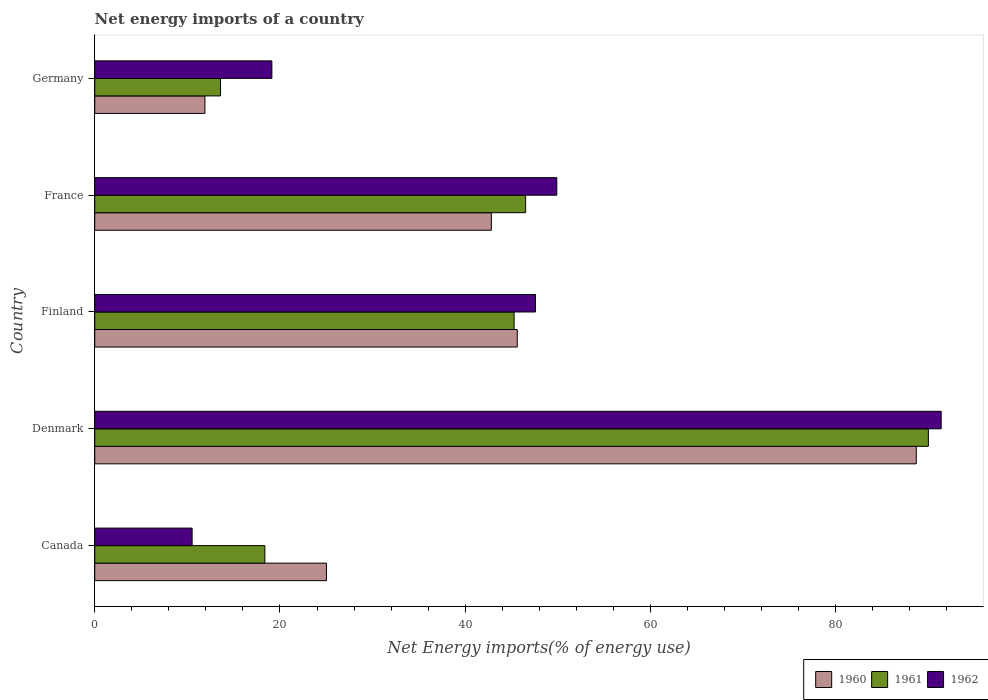How many groups of bars are there?
Keep it short and to the point. 5. Are the number of bars per tick equal to the number of legend labels?
Make the answer very short. Yes. How many bars are there on the 1st tick from the top?
Make the answer very short. 3. How many bars are there on the 1st tick from the bottom?
Offer a terse response. 3. What is the label of the 3rd group of bars from the top?
Make the answer very short. Finland. In how many cases, is the number of bars for a given country not equal to the number of legend labels?
Provide a short and direct response. 0. What is the net energy imports in 1962 in Finland?
Provide a short and direct response. 47.59. Across all countries, what is the maximum net energy imports in 1961?
Your response must be concise. 90.01. Across all countries, what is the minimum net energy imports in 1960?
Make the answer very short. 11.9. In which country was the net energy imports in 1960 maximum?
Provide a succinct answer. Denmark. In which country was the net energy imports in 1961 minimum?
Offer a very short reply. Germany. What is the total net energy imports in 1960 in the graph?
Ensure brevity in your answer.  214.06. What is the difference between the net energy imports in 1962 in Denmark and that in Germany?
Offer a very short reply. 72.26. What is the difference between the net energy imports in 1960 in Canada and the net energy imports in 1961 in Germany?
Make the answer very short. 11.44. What is the average net energy imports in 1962 per country?
Make the answer very short. 43.7. What is the difference between the net energy imports in 1962 and net energy imports in 1961 in Denmark?
Your answer should be very brief. 1.38. What is the ratio of the net energy imports in 1961 in Finland to that in Germany?
Provide a succinct answer. 3.33. Is the net energy imports in 1961 in Denmark less than that in Germany?
Your response must be concise. No. What is the difference between the highest and the second highest net energy imports in 1960?
Keep it short and to the point. 43.08. What is the difference between the highest and the lowest net energy imports in 1962?
Make the answer very short. 80.87. What does the 2nd bar from the top in Germany represents?
Offer a very short reply. 1961. What is the difference between two consecutive major ticks on the X-axis?
Offer a terse response. 20. Are the values on the major ticks of X-axis written in scientific E-notation?
Your answer should be very brief. No. Does the graph contain any zero values?
Your response must be concise. No. Does the graph contain grids?
Ensure brevity in your answer.  No. Where does the legend appear in the graph?
Offer a very short reply. Bottom right. How are the legend labels stacked?
Offer a very short reply. Horizontal. What is the title of the graph?
Provide a short and direct response. Net energy imports of a country. What is the label or title of the X-axis?
Provide a short and direct response. Net Energy imports(% of energy use). What is the Net Energy imports(% of energy use) of 1960 in Canada?
Provide a short and direct response. 25.02. What is the Net Energy imports(% of energy use) of 1961 in Canada?
Make the answer very short. 18.37. What is the Net Energy imports(% of energy use) in 1962 in Canada?
Provide a short and direct response. 10.52. What is the Net Energy imports(% of energy use) of 1960 in Denmark?
Your answer should be compact. 88.7. What is the Net Energy imports(% of energy use) of 1961 in Denmark?
Provide a short and direct response. 90.01. What is the Net Energy imports(% of energy use) of 1962 in Denmark?
Provide a succinct answer. 91.39. What is the Net Energy imports(% of energy use) of 1960 in Finland?
Make the answer very short. 45.62. What is the Net Energy imports(% of energy use) in 1961 in Finland?
Your answer should be compact. 45.28. What is the Net Energy imports(% of energy use) of 1962 in Finland?
Offer a terse response. 47.59. What is the Net Energy imports(% of energy use) of 1960 in France?
Give a very brief answer. 42.82. What is the Net Energy imports(% of energy use) of 1961 in France?
Ensure brevity in your answer.  46.52. What is the Net Energy imports(% of energy use) of 1962 in France?
Provide a short and direct response. 49.89. What is the Net Energy imports(% of energy use) in 1960 in Germany?
Your answer should be compact. 11.9. What is the Net Energy imports(% of energy use) of 1961 in Germany?
Provide a succinct answer. 13.58. What is the Net Energy imports(% of energy use) in 1962 in Germany?
Your answer should be very brief. 19.13. Across all countries, what is the maximum Net Energy imports(% of energy use) in 1960?
Your response must be concise. 88.7. Across all countries, what is the maximum Net Energy imports(% of energy use) of 1961?
Your answer should be very brief. 90.01. Across all countries, what is the maximum Net Energy imports(% of energy use) of 1962?
Your answer should be very brief. 91.39. Across all countries, what is the minimum Net Energy imports(% of energy use) in 1960?
Your response must be concise. 11.9. Across all countries, what is the minimum Net Energy imports(% of energy use) in 1961?
Provide a short and direct response. 13.58. Across all countries, what is the minimum Net Energy imports(% of energy use) of 1962?
Your response must be concise. 10.52. What is the total Net Energy imports(% of energy use) in 1960 in the graph?
Keep it short and to the point. 214.06. What is the total Net Energy imports(% of energy use) in 1961 in the graph?
Provide a short and direct response. 213.76. What is the total Net Energy imports(% of energy use) of 1962 in the graph?
Your answer should be compact. 218.51. What is the difference between the Net Energy imports(% of energy use) in 1960 in Canada and that in Denmark?
Provide a short and direct response. -63.68. What is the difference between the Net Energy imports(% of energy use) of 1961 in Canada and that in Denmark?
Your answer should be very brief. -71.64. What is the difference between the Net Energy imports(% of energy use) of 1962 in Canada and that in Denmark?
Your response must be concise. -80.87. What is the difference between the Net Energy imports(% of energy use) of 1960 in Canada and that in Finland?
Your answer should be very brief. -20.6. What is the difference between the Net Energy imports(% of energy use) in 1961 in Canada and that in Finland?
Offer a terse response. -26.91. What is the difference between the Net Energy imports(% of energy use) in 1962 in Canada and that in Finland?
Offer a terse response. -37.08. What is the difference between the Net Energy imports(% of energy use) in 1960 in Canada and that in France?
Provide a succinct answer. -17.8. What is the difference between the Net Energy imports(% of energy use) of 1961 in Canada and that in France?
Offer a very short reply. -28.15. What is the difference between the Net Energy imports(% of energy use) of 1962 in Canada and that in France?
Your answer should be very brief. -39.37. What is the difference between the Net Energy imports(% of energy use) of 1960 in Canada and that in Germany?
Your answer should be compact. 13.12. What is the difference between the Net Energy imports(% of energy use) in 1961 in Canada and that in Germany?
Give a very brief answer. 4.79. What is the difference between the Net Energy imports(% of energy use) of 1962 in Canada and that in Germany?
Your answer should be compact. -8.61. What is the difference between the Net Energy imports(% of energy use) of 1960 in Denmark and that in Finland?
Your answer should be very brief. 43.08. What is the difference between the Net Energy imports(% of energy use) of 1961 in Denmark and that in Finland?
Offer a very short reply. 44.73. What is the difference between the Net Energy imports(% of energy use) in 1962 in Denmark and that in Finland?
Offer a terse response. 43.8. What is the difference between the Net Energy imports(% of energy use) in 1960 in Denmark and that in France?
Keep it short and to the point. 45.88. What is the difference between the Net Energy imports(% of energy use) of 1961 in Denmark and that in France?
Give a very brief answer. 43.49. What is the difference between the Net Energy imports(% of energy use) in 1962 in Denmark and that in France?
Provide a succinct answer. 41.5. What is the difference between the Net Energy imports(% of energy use) of 1960 in Denmark and that in Germany?
Your response must be concise. 76.8. What is the difference between the Net Energy imports(% of energy use) in 1961 in Denmark and that in Germany?
Provide a short and direct response. 76.43. What is the difference between the Net Energy imports(% of energy use) in 1962 in Denmark and that in Germany?
Your answer should be compact. 72.26. What is the difference between the Net Energy imports(% of energy use) of 1960 in Finland and that in France?
Your answer should be compact. 2.8. What is the difference between the Net Energy imports(% of energy use) of 1961 in Finland and that in France?
Ensure brevity in your answer.  -1.24. What is the difference between the Net Energy imports(% of energy use) of 1962 in Finland and that in France?
Ensure brevity in your answer.  -2.3. What is the difference between the Net Energy imports(% of energy use) of 1960 in Finland and that in Germany?
Your response must be concise. 33.72. What is the difference between the Net Energy imports(% of energy use) in 1961 in Finland and that in Germany?
Your response must be concise. 31.7. What is the difference between the Net Energy imports(% of energy use) in 1962 in Finland and that in Germany?
Offer a terse response. 28.47. What is the difference between the Net Energy imports(% of energy use) in 1960 in France and that in Germany?
Offer a very short reply. 30.93. What is the difference between the Net Energy imports(% of energy use) in 1961 in France and that in Germany?
Offer a terse response. 32.94. What is the difference between the Net Energy imports(% of energy use) in 1962 in France and that in Germany?
Your answer should be very brief. 30.76. What is the difference between the Net Energy imports(% of energy use) in 1960 in Canada and the Net Energy imports(% of energy use) in 1961 in Denmark?
Provide a short and direct response. -64.99. What is the difference between the Net Energy imports(% of energy use) in 1960 in Canada and the Net Energy imports(% of energy use) in 1962 in Denmark?
Your answer should be very brief. -66.37. What is the difference between the Net Energy imports(% of energy use) in 1961 in Canada and the Net Energy imports(% of energy use) in 1962 in Denmark?
Provide a succinct answer. -73.02. What is the difference between the Net Energy imports(% of energy use) in 1960 in Canada and the Net Energy imports(% of energy use) in 1961 in Finland?
Your answer should be compact. -20.26. What is the difference between the Net Energy imports(% of energy use) in 1960 in Canada and the Net Energy imports(% of energy use) in 1962 in Finland?
Your response must be concise. -22.57. What is the difference between the Net Energy imports(% of energy use) of 1961 in Canada and the Net Energy imports(% of energy use) of 1962 in Finland?
Give a very brief answer. -29.22. What is the difference between the Net Energy imports(% of energy use) of 1960 in Canada and the Net Energy imports(% of energy use) of 1961 in France?
Make the answer very short. -21.5. What is the difference between the Net Energy imports(% of energy use) of 1960 in Canada and the Net Energy imports(% of energy use) of 1962 in France?
Provide a succinct answer. -24.87. What is the difference between the Net Energy imports(% of energy use) in 1961 in Canada and the Net Energy imports(% of energy use) in 1962 in France?
Your answer should be compact. -31.52. What is the difference between the Net Energy imports(% of energy use) of 1960 in Canada and the Net Energy imports(% of energy use) of 1961 in Germany?
Give a very brief answer. 11.44. What is the difference between the Net Energy imports(% of energy use) of 1960 in Canada and the Net Energy imports(% of energy use) of 1962 in Germany?
Offer a terse response. 5.89. What is the difference between the Net Energy imports(% of energy use) in 1961 in Canada and the Net Energy imports(% of energy use) in 1962 in Germany?
Your response must be concise. -0.76. What is the difference between the Net Energy imports(% of energy use) in 1960 in Denmark and the Net Energy imports(% of energy use) in 1961 in Finland?
Provide a short and direct response. 43.42. What is the difference between the Net Energy imports(% of energy use) of 1960 in Denmark and the Net Energy imports(% of energy use) of 1962 in Finland?
Keep it short and to the point. 41.11. What is the difference between the Net Energy imports(% of energy use) of 1961 in Denmark and the Net Energy imports(% of energy use) of 1962 in Finland?
Provide a succinct answer. 42.42. What is the difference between the Net Energy imports(% of energy use) of 1960 in Denmark and the Net Energy imports(% of energy use) of 1961 in France?
Provide a short and direct response. 42.18. What is the difference between the Net Energy imports(% of energy use) of 1960 in Denmark and the Net Energy imports(% of energy use) of 1962 in France?
Your answer should be very brief. 38.81. What is the difference between the Net Energy imports(% of energy use) in 1961 in Denmark and the Net Energy imports(% of energy use) in 1962 in France?
Provide a succinct answer. 40.12. What is the difference between the Net Energy imports(% of energy use) in 1960 in Denmark and the Net Energy imports(% of energy use) in 1961 in Germany?
Offer a terse response. 75.12. What is the difference between the Net Energy imports(% of energy use) in 1960 in Denmark and the Net Energy imports(% of energy use) in 1962 in Germany?
Make the answer very short. 69.58. What is the difference between the Net Energy imports(% of energy use) of 1961 in Denmark and the Net Energy imports(% of energy use) of 1962 in Germany?
Your response must be concise. 70.88. What is the difference between the Net Energy imports(% of energy use) in 1960 in Finland and the Net Energy imports(% of energy use) in 1961 in France?
Provide a short and direct response. -0.9. What is the difference between the Net Energy imports(% of energy use) in 1960 in Finland and the Net Energy imports(% of energy use) in 1962 in France?
Your response must be concise. -4.27. What is the difference between the Net Energy imports(% of energy use) in 1961 in Finland and the Net Energy imports(% of energy use) in 1962 in France?
Your answer should be very brief. -4.61. What is the difference between the Net Energy imports(% of energy use) in 1960 in Finland and the Net Energy imports(% of energy use) in 1961 in Germany?
Your response must be concise. 32.04. What is the difference between the Net Energy imports(% of energy use) of 1960 in Finland and the Net Energy imports(% of energy use) of 1962 in Germany?
Offer a very short reply. 26.49. What is the difference between the Net Energy imports(% of energy use) of 1961 in Finland and the Net Energy imports(% of energy use) of 1962 in Germany?
Ensure brevity in your answer.  26.15. What is the difference between the Net Energy imports(% of energy use) of 1960 in France and the Net Energy imports(% of energy use) of 1961 in Germany?
Your answer should be very brief. 29.24. What is the difference between the Net Energy imports(% of energy use) of 1960 in France and the Net Energy imports(% of energy use) of 1962 in Germany?
Your response must be concise. 23.7. What is the difference between the Net Energy imports(% of energy use) in 1961 in France and the Net Energy imports(% of energy use) in 1962 in Germany?
Provide a short and direct response. 27.39. What is the average Net Energy imports(% of energy use) of 1960 per country?
Make the answer very short. 42.81. What is the average Net Energy imports(% of energy use) in 1961 per country?
Provide a succinct answer. 42.75. What is the average Net Energy imports(% of energy use) in 1962 per country?
Your answer should be very brief. 43.7. What is the difference between the Net Energy imports(% of energy use) in 1960 and Net Energy imports(% of energy use) in 1961 in Canada?
Offer a very short reply. 6.65. What is the difference between the Net Energy imports(% of energy use) in 1960 and Net Energy imports(% of energy use) in 1962 in Canada?
Offer a very short reply. 14.5. What is the difference between the Net Energy imports(% of energy use) of 1961 and Net Energy imports(% of energy use) of 1962 in Canada?
Ensure brevity in your answer.  7.85. What is the difference between the Net Energy imports(% of energy use) in 1960 and Net Energy imports(% of energy use) in 1961 in Denmark?
Your answer should be very brief. -1.31. What is the difference between the Net Energy imports(% of energy use) in 1960 and Net Energy imports(% of energy use) in 1962 in Denmark?
Offer a terse response. -2.69. What is the difference between the Net Energy imports(% of energy use) of 1961 and Net Energy imports(% of energy use) of 1962 in Denmark?
Your answer should be compact. -1.38. What is the difference between the Net Energy imports(% of energy use) in 1960 and Net Energy imports(% of energy use) in 1961 in Finland?
Offer a very short reply. 0.34. What is the difference between the Net Energy imports(% of energy use) in 1960 and Net Energy imports(% of energy use) in 1962 in Finland?
Keep it short and to the point. -1.97. What is the difference between the Net Energy imports(% of energy use) in 1961 and Net Energy imports(% of energy use) in 1962 in Finland?
Ensure brevity in your answer.  -2.31. What is the difference between the Net Energy imports(% of energy use) of 1960 and Net Energy imports(% of energy use) of 1961 in France?
Make the answer very short. -3.7. What is the difference between the Net Energy imports(% of energy use) of 1960 and Net Energy imports(% of energy use) of 1962 in France?
Keep it short and to the point. -7.06. What is the difference between the Net Energy imports(% of energy use) in 1961 and Net Energy imports(% of energy use) in 1962 in France?
Offer a terse response. -3.37. What is the difference between the Net Energy imports(% of energy use) of 1960 and Net Energy imports(% of energy use) of 1961 in Germany?
Provide a short and direct response. -1.68. What is the difference between the Net Energy imports(% of energy use) of 1960 and Net Energy imports(% of energy use) of 1962 in Germany?
Keep it short and to the point. -7.23. What is the difference between the Net Energy imports(% of energy use) in 1961 and Net Energy imports(% of energy use) in 1962 in Germany?
Offer a very short reply. -5.54. What is the ratio of the Net Energy imports(% of energy use) of 1960 in Canada to that in Denmark?
Your response must be concise. 0.28. What is the ratio of the Net Energy imports(% of energy use) of 1961 in Canada to that in Denmark?
Provide a succinct answer. 0.2. What is the ratio of the Net Energy imports(% of energy use) of 1962 in Canada to that in Denmark?
Ensure brevity in your answer.  0.12. What is the ratio of the Net Energy imports(% of energy use) of 1960 in Canada to that in Finland?
Keep it short and to the point. 0.55. What is the ratio of the Net Energy imports(% of energy use) in 1961 in Canada to that in Finland?
Offer a terse response. 0.41. What is the ratio of the Net Energy imports(% of energy use) in 1962 in Canada to that in Finland?
Make the answer very short. 0.22. What is the ratio of the Net Energy imports(% of energy use) of 1960 in Canada to that in France?
Your response must be concise. 0.58. What is the ratio of the Net Energy imports(% of energy use) of 1961 in Canada to that in France?
Your answer should be very brief. 0.39. What is the ratio of the Net Energy imports(% of energy use) of 1962 in Canada to that in France?
Ensure brevity in your answer.  0.21. What is the ratio of the Net Energy imports(% of energy use) of 1960 in Canada to that in Germany?
Your response must be concise. 2.1. What is the ratio of the Net Energy imports(% of energy use) in 1961 in Canada to that in Germany?
Keep it short and to the point. 1.35. What is the ratio of the Net Energy imports(% of energy use) of 1962 in Canada to that in Germany?
Your response must be concise. 0.55. What is the ratio of the Net Energy imports(% of energy use) in 1960 in Denmark to that in Finland?
Ensure brevity in your answer.  1.94. What is the ratio of the Net Energy imports(% of energy use) in 1961 in Denmark to that in Finland?
Your response must be concise. 1.99. What is the ratio of the Net Energy imports(% of energy use) of 1962 in Denmark to that in Finland?
Provide a short and direct response. 1.92. What is the ratio of the Net Energy imports(% of energy use) in 1960 in Denmark to that in France?
Ensure brevity in your answer.  2.07. What is the ratio of the Net Energy imports(% of energy use) in 1961 in Denmark to that in France?
Your response must be concise. 1.93. What is the ratio of the Net Energy imports(% of energy use) in 1962 in Denmark to that in France?
Provide a succinct answer. 1.83. What is the ratio of the Net Energy imports(% of energy use) of 1960 in Denmark to that in Germany?
Give a very brief answer. 7.46. What is the ratio of the Net Energy imports(% of energy use) of 1961 in Denmark to that in Germany?
Make the answer very short. 6.63. What is the ratio of the Net Energy imports(% of energy use) in 1962 in Denmark to that in Germany?
Your answer should be compact. 4.78. What is the ratio of the Net Energy imports(% of energy use) in 1960 in Finland to that in France?
Ensure brevity in your answer.  1.07. What is the ratio of the Net Energy imports(% of energy use) in 1961 in Finland to that in France?
Keep it short and to the point. 0.97. What is the ratio of the Net Energy imports(% of energy use) of 1962 in Finland to that in France?
Offer a very short reply. 0.95. What is the ratio of the Net Energy imports(% of energy use) in 1960 in Finland to that in Germany?
Offer a terse response. 3.83. What is the ratio of the Net Energy imports(% of energy use) of 1961 in Finland to that in Germany?
Provide a short and direct response. 3.33. What is the ratio of the Net Energy imports(% of energy use) of 1962 in Finland to that in Germany?
Keep it short and to the point. 2.49. What is the ratio of the Net Energy imports(% of energy use) in 1960 in France to that in Germany?
Your answer should be very brief. 3.6. What is the ratio of the Net Energy imports(% of energy use) in 1961 in France to that in Germany?
Ensure brevity in your answer.  3.43. What is the ratio of the Net Energy imports(% of energy use) in 1962 in France to that in Germany?
Your answer should be very brief. 2.61. What is the difference between the highest and the second highest Net Energy imports(% of energy use) of 1960?
Offer a terse response. 43.08. What is the difference between the highest and the second highest Net Energy imports(% of energy use) of 1961?
Provide a succinct answer. 43.49. What is the difference between the highest and the second highest Net Energy imports(% of energy use) in 1962?
Ensure brevity in your answer.  41.5. What is the difference between the highest and the lowest Net Energy imports(% of energy use) in 1960?
Your answer should be very brief. 76.8. What is the difference between the highest and the lowest Net Energy imports(% of energy use) in 1961?
Your answer should be very brief. 76.43. What is the difference between the highest and the lowest Net Energy imports(% of energy use) of 1962?
Provide a short and direct response. 80.87. 